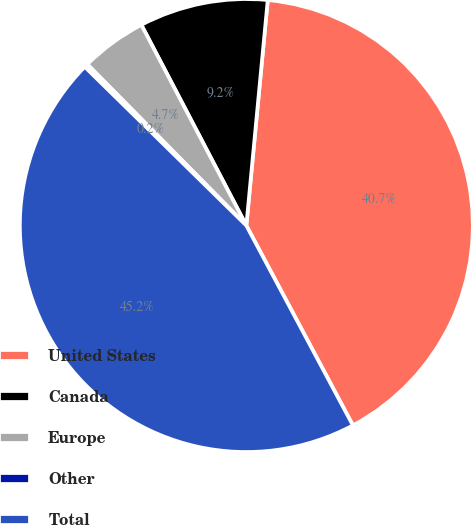Convert chart. <chart><loc_0><loc_0><loc_500><loc_500><pie_chart><fcel>United States<fcel>Canada<fcel>Europe<fcel>Other<fcel>Total<nl><fcel>40.7%<fcel>9.18%<fcel>4.72%<fcel>0.25%<fcel>45.16%<nl></chart> 